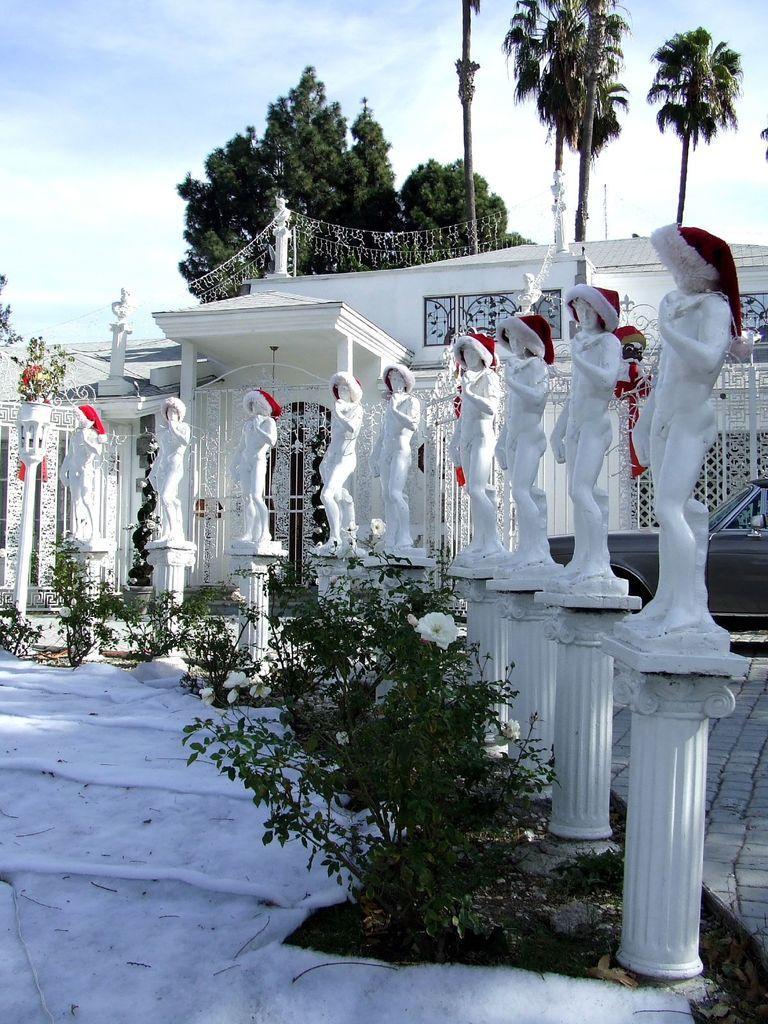Please provide a concise description of this image. On the ground there is snow. Also there are plants with flowers. Near to that there are statues on the pillars. On the statues there are caps. Also there is a building and a car. In the background there are trees and sky. 